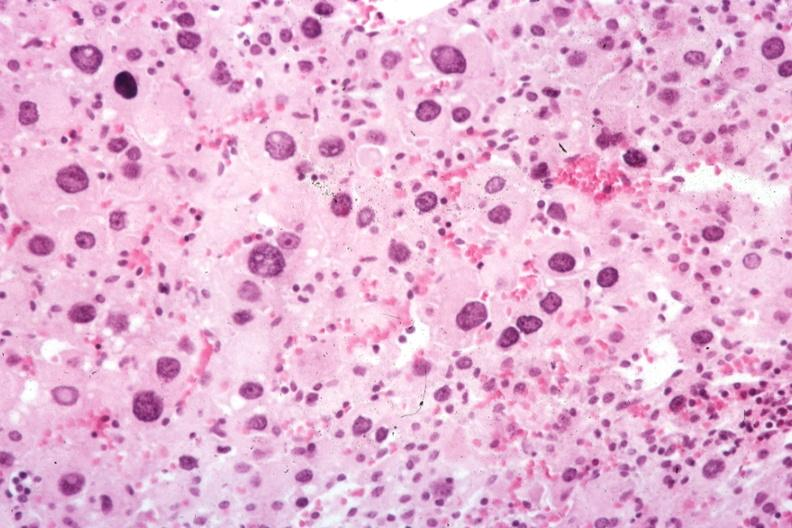s endocrine present?
Answer the question using a single word or phrase. Yes 